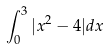Convert formula to latex. <formula><loc_0><loc_0><loc_500><loc_500>\int _ { 0 } ^ { 3 } | x ^ { 2 } - 4 | d x</formula> 